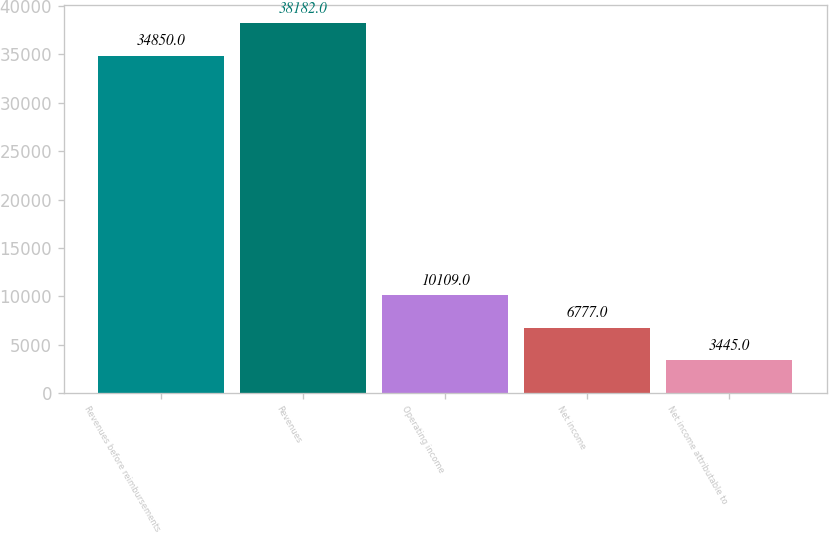Convert chart to OTSL. <chart><loc_0><loc_0><loc_500><loc_500><bar_chart><fcel>Revenues before reimbursements<fcel>Revenues<fcel>Operating income<fcel>Net income<fcel>Net income attributable to<nl><fcel>34850<fcel>38182<fcel>10109<fcel>6777<fcel>3445<nl></chart> 